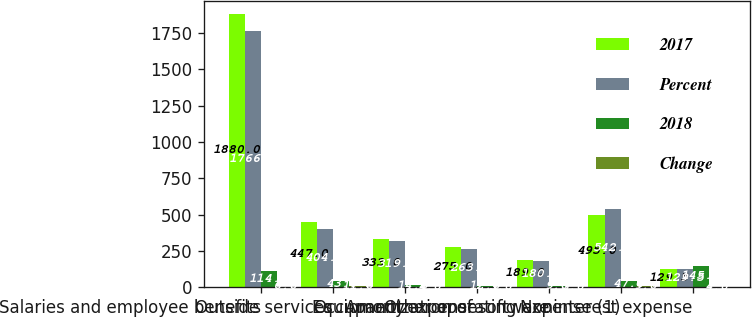Convert chart. <chart><loc_0><loc_0><loc_500><loc_500><stacked_bar_chart><ecel><fcel>Salaries and employee benefits<fcel>Outside services<fcel>Occupancy<fcel>Equipment expense<fcel>Amortization of software<fcel>Other operating expense (1)<fcel>Noninterest expense<nl><fcel>2017<fcel>1880<fcel>447<fcel>333<fcel>275<fcel>189<fcel>495<fcel>129.5<nl><fcel>Percent<fcel>1766<fcel>404<fcel>319<fcel>263<fcel>180<fcel>542<fcel>129.5<nl><fcel>2018<fcel>114<fcel>43<fcel>14<fcel>12<fcel>9<fcel>47<fcel>145<nl><fcel>Change<fcel>6<fcel>11<fcel>4<fcel>5<fcel>5<fcel>9<fcel>4<nl></chart> 